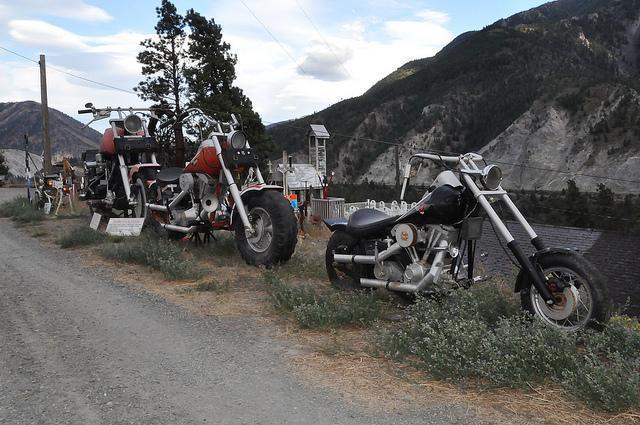How many motorcycles are in the photo?
Give a very brief answer. 3. 